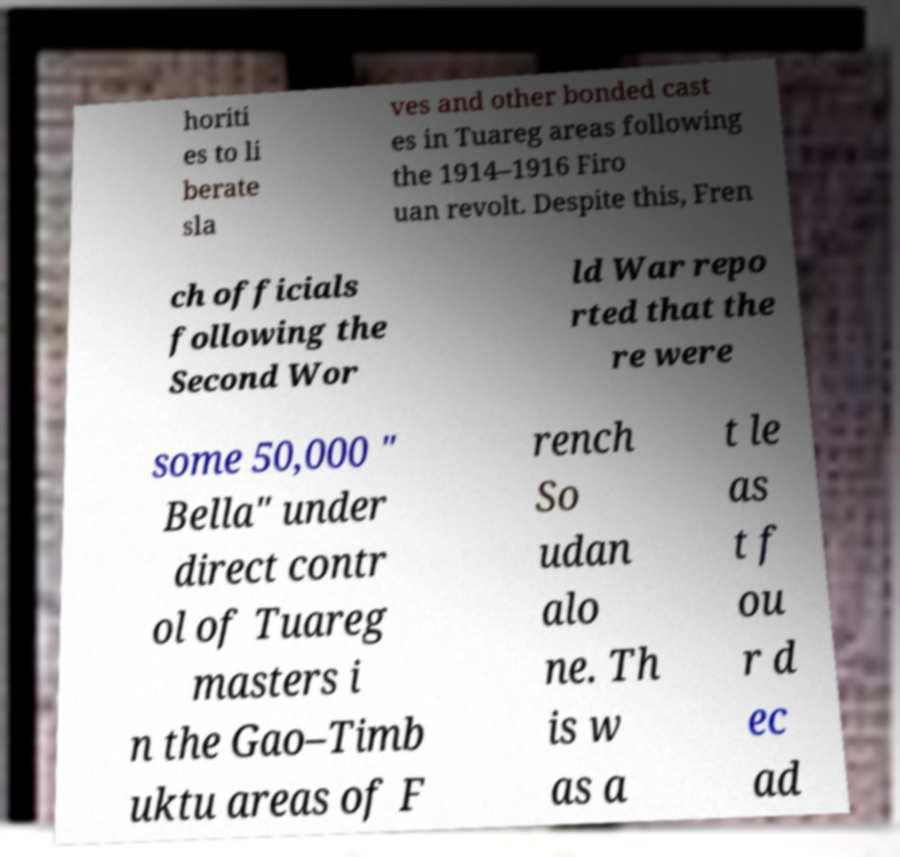Please read and relay the text visible in this image. What does it say? horiti es to li berate sla ves and other bonded cast es in Tuareg areas following the 1914–1916 Firo uan revolt. Despite this, Fren ch officials following the Second Wor ld War repo rted that the re were some 50,000 " Bella" under direct contr ol of Tuareg masters i n the Gao–Timb uktu areas of F rench So udan alo ne. Th is w as a t le as t f ou r d ec ad 